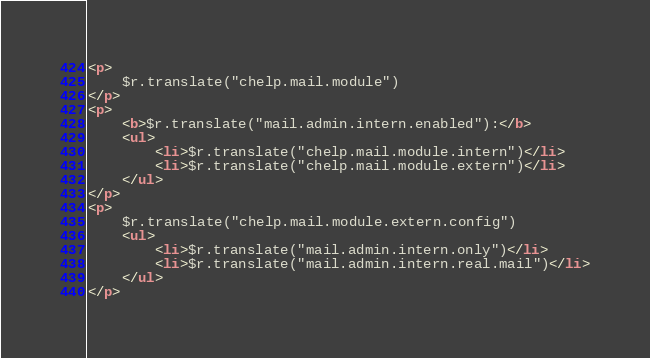Convert code to text. <code><loc_0><loc_0><loc_500><loc_500><_HTML_><p>
	$r.translate("chelp.mail.module")
</p>
<p>
	<b>$r.translate("mail.admin.intern.enabled"):</b>
	<ul>
		<li>$r.translate("chelp.mail.module.intern")</li>
		<li>$r.translate("chelp.mail.module.extern")</li>
	</ul>
</p>
<p>
	$r.translate("chelp.mail.module.extern.config")
	<ul>
		<li>$r.translate("mail.admin.intern.only")</li>
		<li>$r.translate("mail.admin.intern.real.mail")</li>
	</ul>
</p>
</code> 